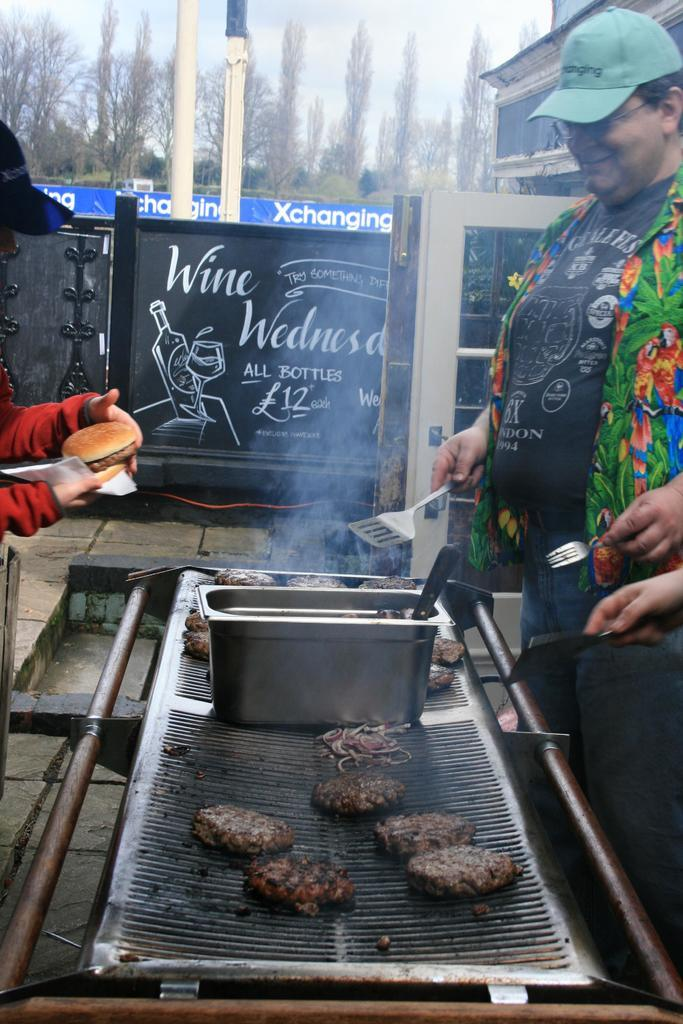<image>
Give a short and clear explanation of the subsequent image. the word wine is on the black and white board 